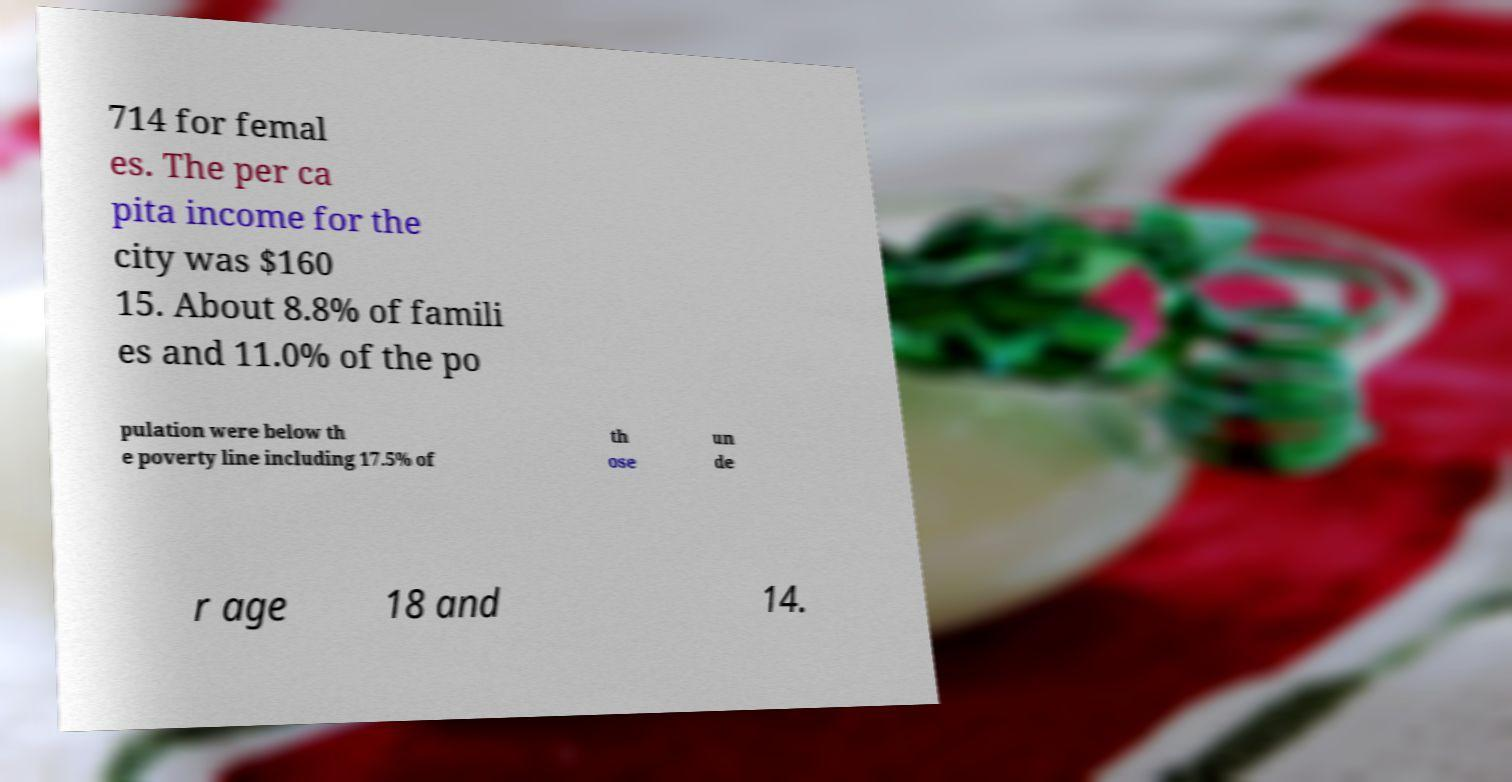Can you accurately transcribe the text from the provided image for me? 714 for femal es. The per ca pita income for the city was $160 15. About 8.8% of famili es and 11.0% of the po pulation were below th e poverty line including 17.5% of th ose un de r age 18 and 14. 